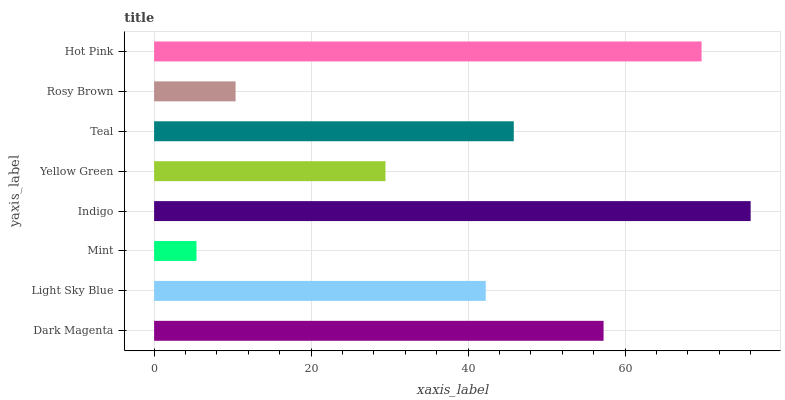Is Mint the minimum?
Answer yes or no. Yes. Is Indigo the maximum?
Answer yes or no. Yes. Is Light Sky Blue the minimum?
Answer yes or no. No. Is Light Sky Blue the maximum?
Answer yes or no. No. Is Dark Magenta greater than Light Sky Blue?
Answer yes or no. Yes. Is Light Sky Blue less than Dark Magenta?
Answer yes or no. Yes. Is Light Sky Blue greater than Dark Magenta?
Answer yes or no. No. Is Dark Magenta less than Light Sky Blue?
Answer yes or no. No. Is Teal the high median?
Answer yes or no. Yes. Is Light Sky Blue the low median?
Answer yes or no. Yes. Is Yellow Green the high median?
Answer yes or no. No. Is Indigo the low median?
Answer yes or no. No. 